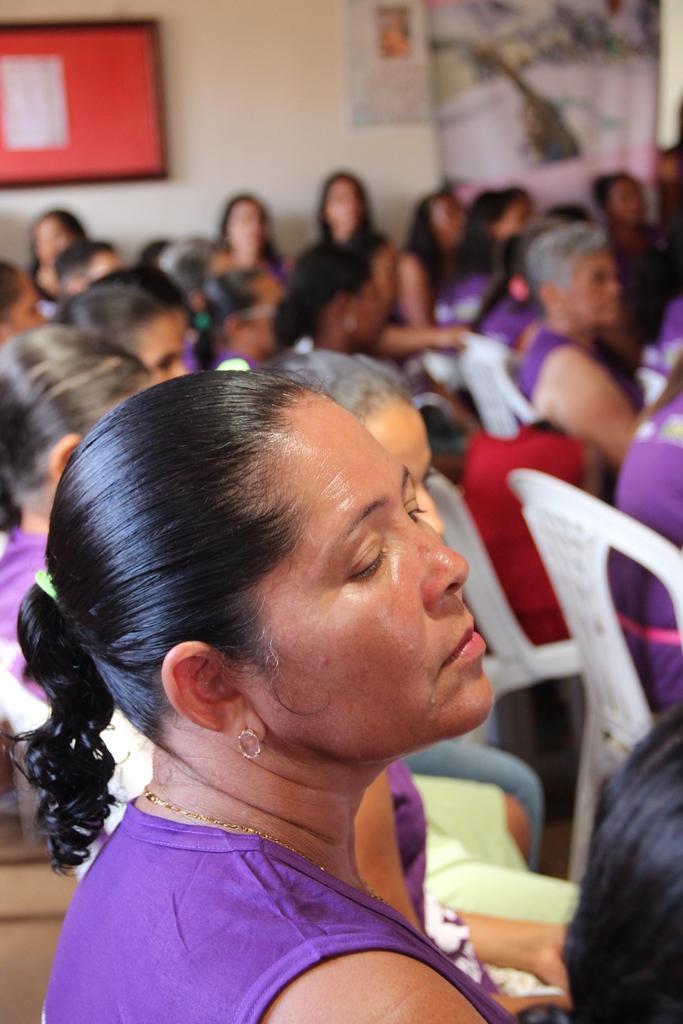Describe this image in one or two sentences. In the foreground of the image there is a lady. In the background of the image there are people sitting on chairs. There is wall. There is a board. 